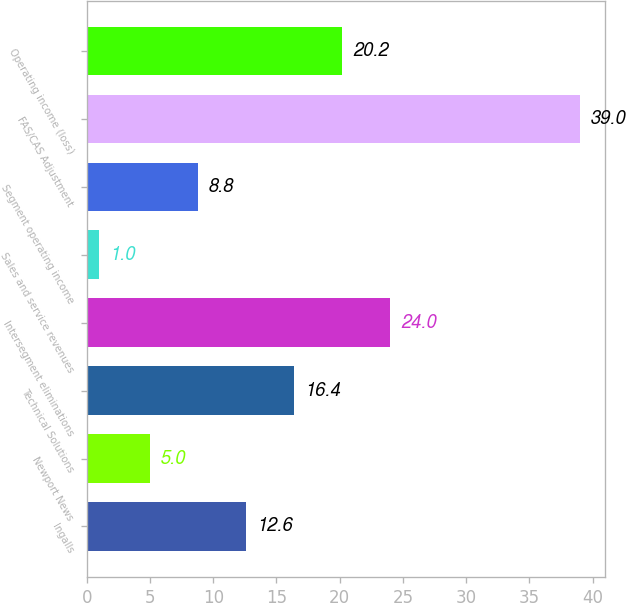<chart> <loc_0><loc_0><loc_500><loc_500><bar_chart><fcel>Ingalls<fcel>Newport News<fcel>Technical Solutions<fcel>Intersegment eliminations<fcel>Sales and service revenues<fcel>Segment operating income<fcel>FAS/CAS Adjustment<fcel>Operating income (loss)<nl><fcel>12.6<fcel>5<fcel>16.4<fcel>24<fcel>1<fcel>8.8<fcel>39<fcel>20.2<nl></chart> 